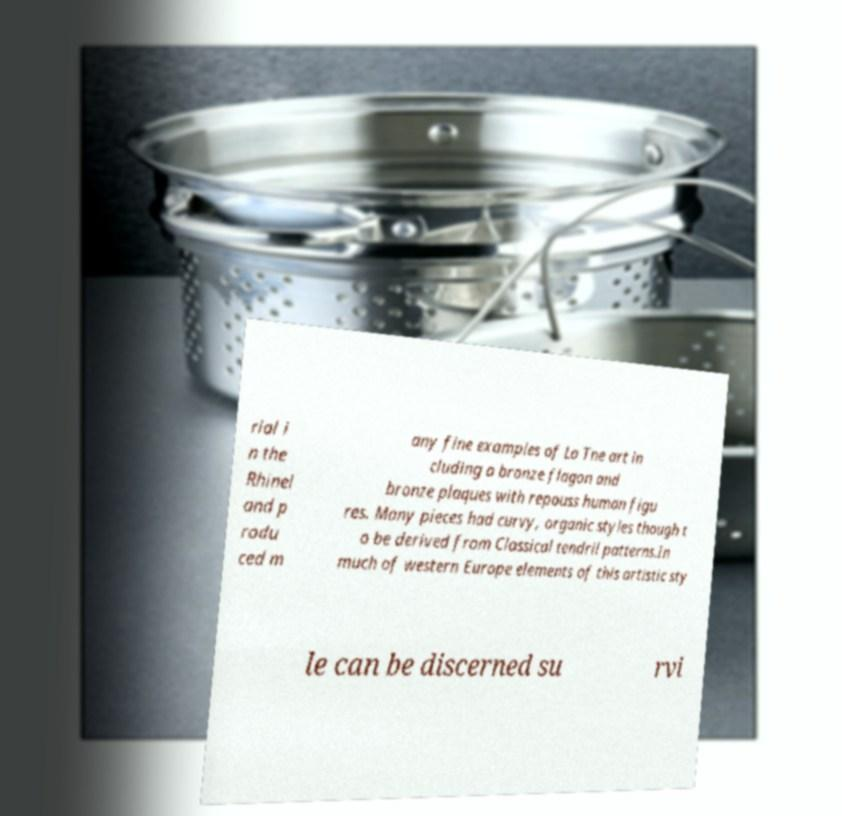Could you extract and type out the text from this image? rial i n the Rhinel and p rodu ced m any fine examples of La Tne art in cluding a bronze flagon and bronze plaques with repouss human figu res. Many pieces had curvy, organic styles though t o be derived from Classical tendril patterns.In much of western Europe elements of this artistic sty le can be discerned su rvi 